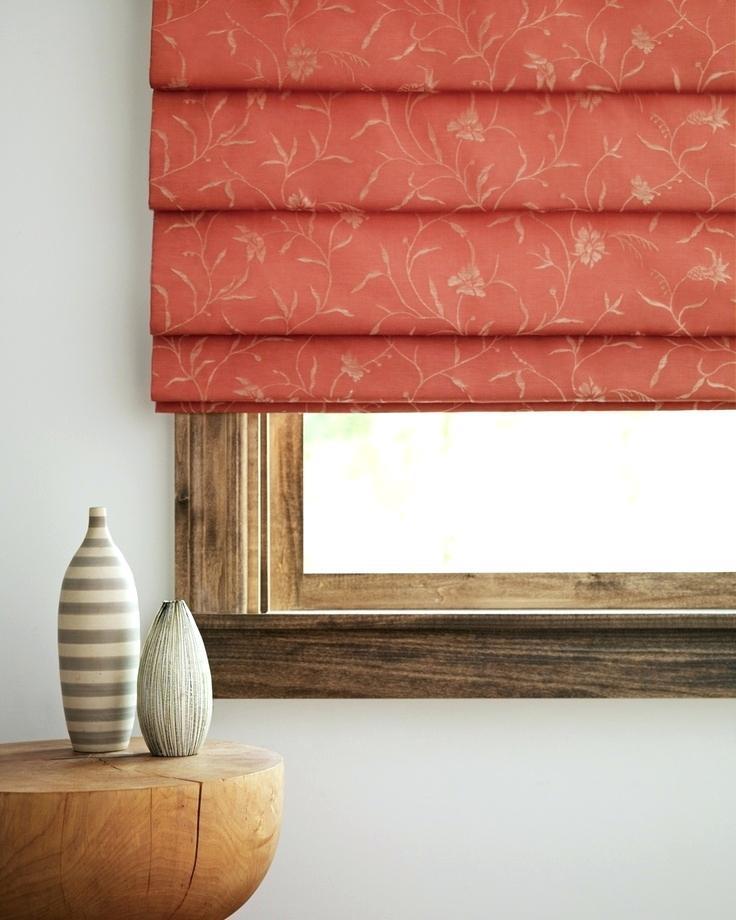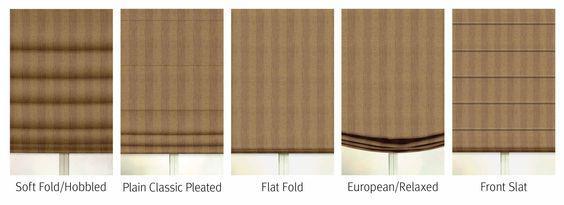The first image is the image on the left, the second image is the image on the right. Assess this claim about the two images: "One of the images shows windows and curtains with no surrounding room.". Correct or not? Answer yes or no. Yes. The first image is the image on the left, the second image is the image on the right. For the images shown, is this caption "The left and right image contains the same number of blinds." true? Answer yes or no. No. 